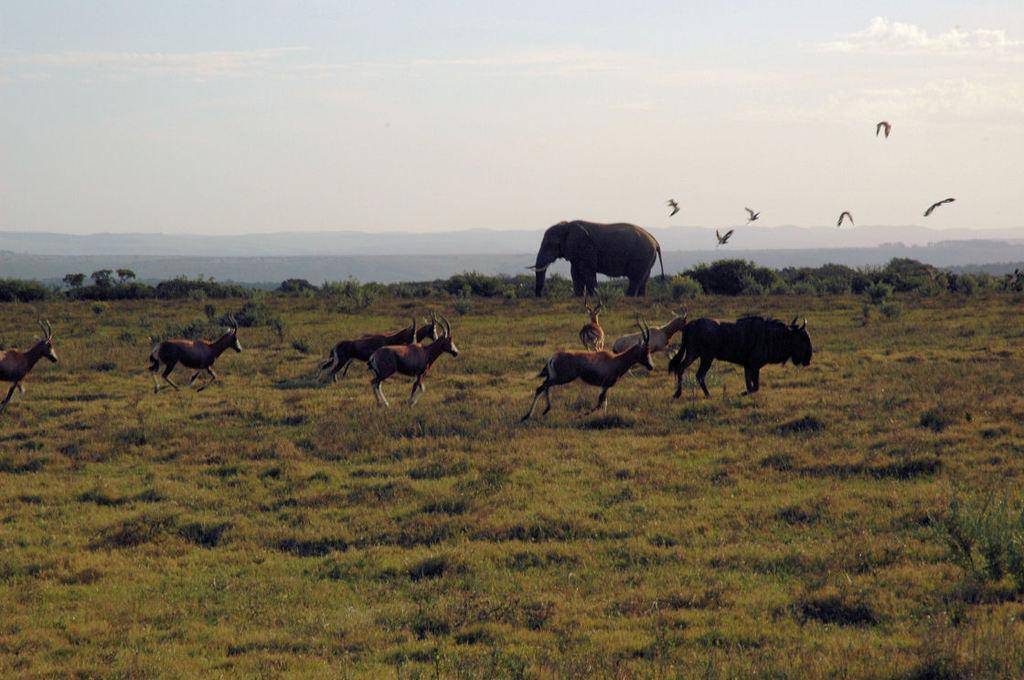Could you give a brief overview of what you see in this image? In the center of the image there are animals. In the background of the image there are mountains, birds, elephant, sky. At the bottom of the image there is grass. 